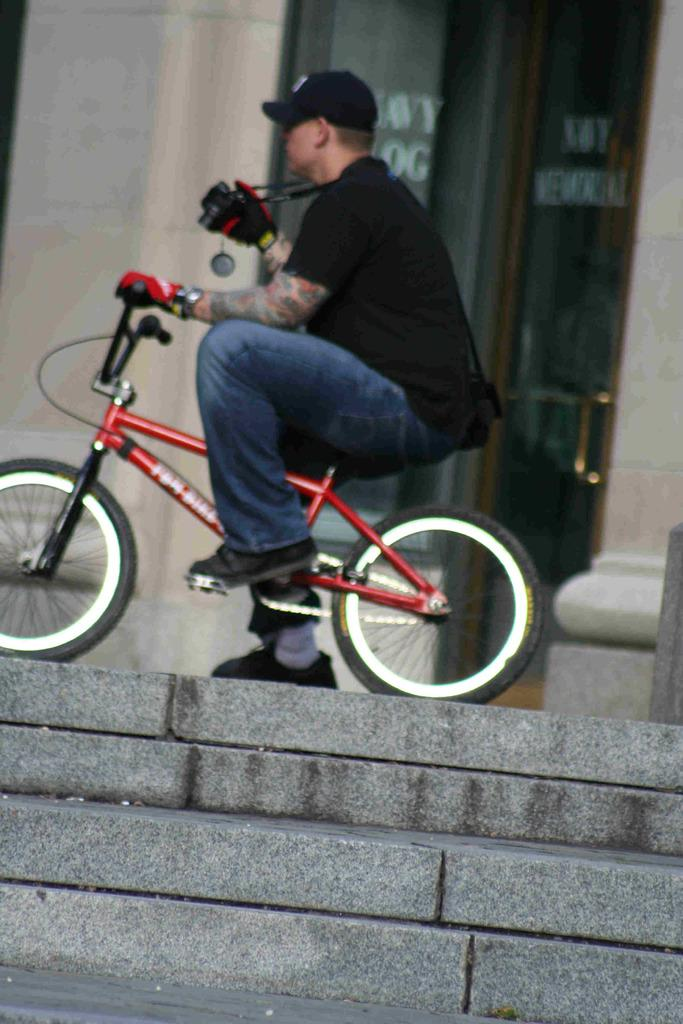Who is the person in the image? There is a man in the image. What is the man doing in the image? The man is on a cycle. What architectural feature can be seen in the image? There are stairs visible in the image. What type of necklace is the man wearing in the image? The man is not wearing a necklace in the image. How does the man's journey on the cycle relate to the edge of the image? The man's journey on the cycle does not relate to the edge of the image, as there is no mention of a journey or an edge in the provided facts. 